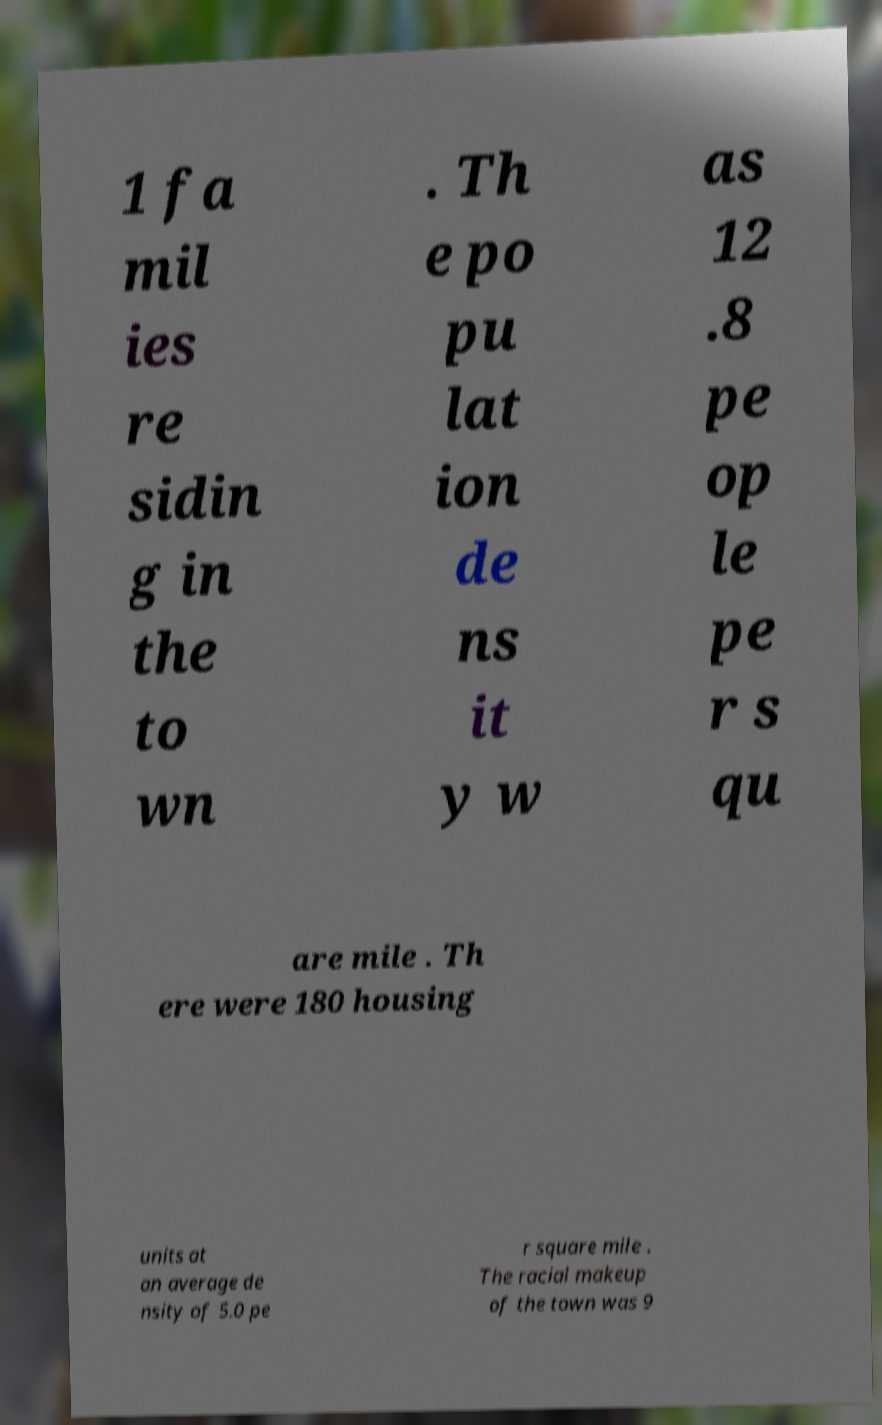There's text embedded in this image that I need extracted. Can you transcribe it verbatim? 1 fa mil ies re sidin g in the to wn . Th e po pu lat ion de ns it y w as 12 .8 pe op le pe r s qu are mile . Th ere were 180 housing units at an average de nsity of 5.0 pe r square mile . The racial makeup of the town was 9 